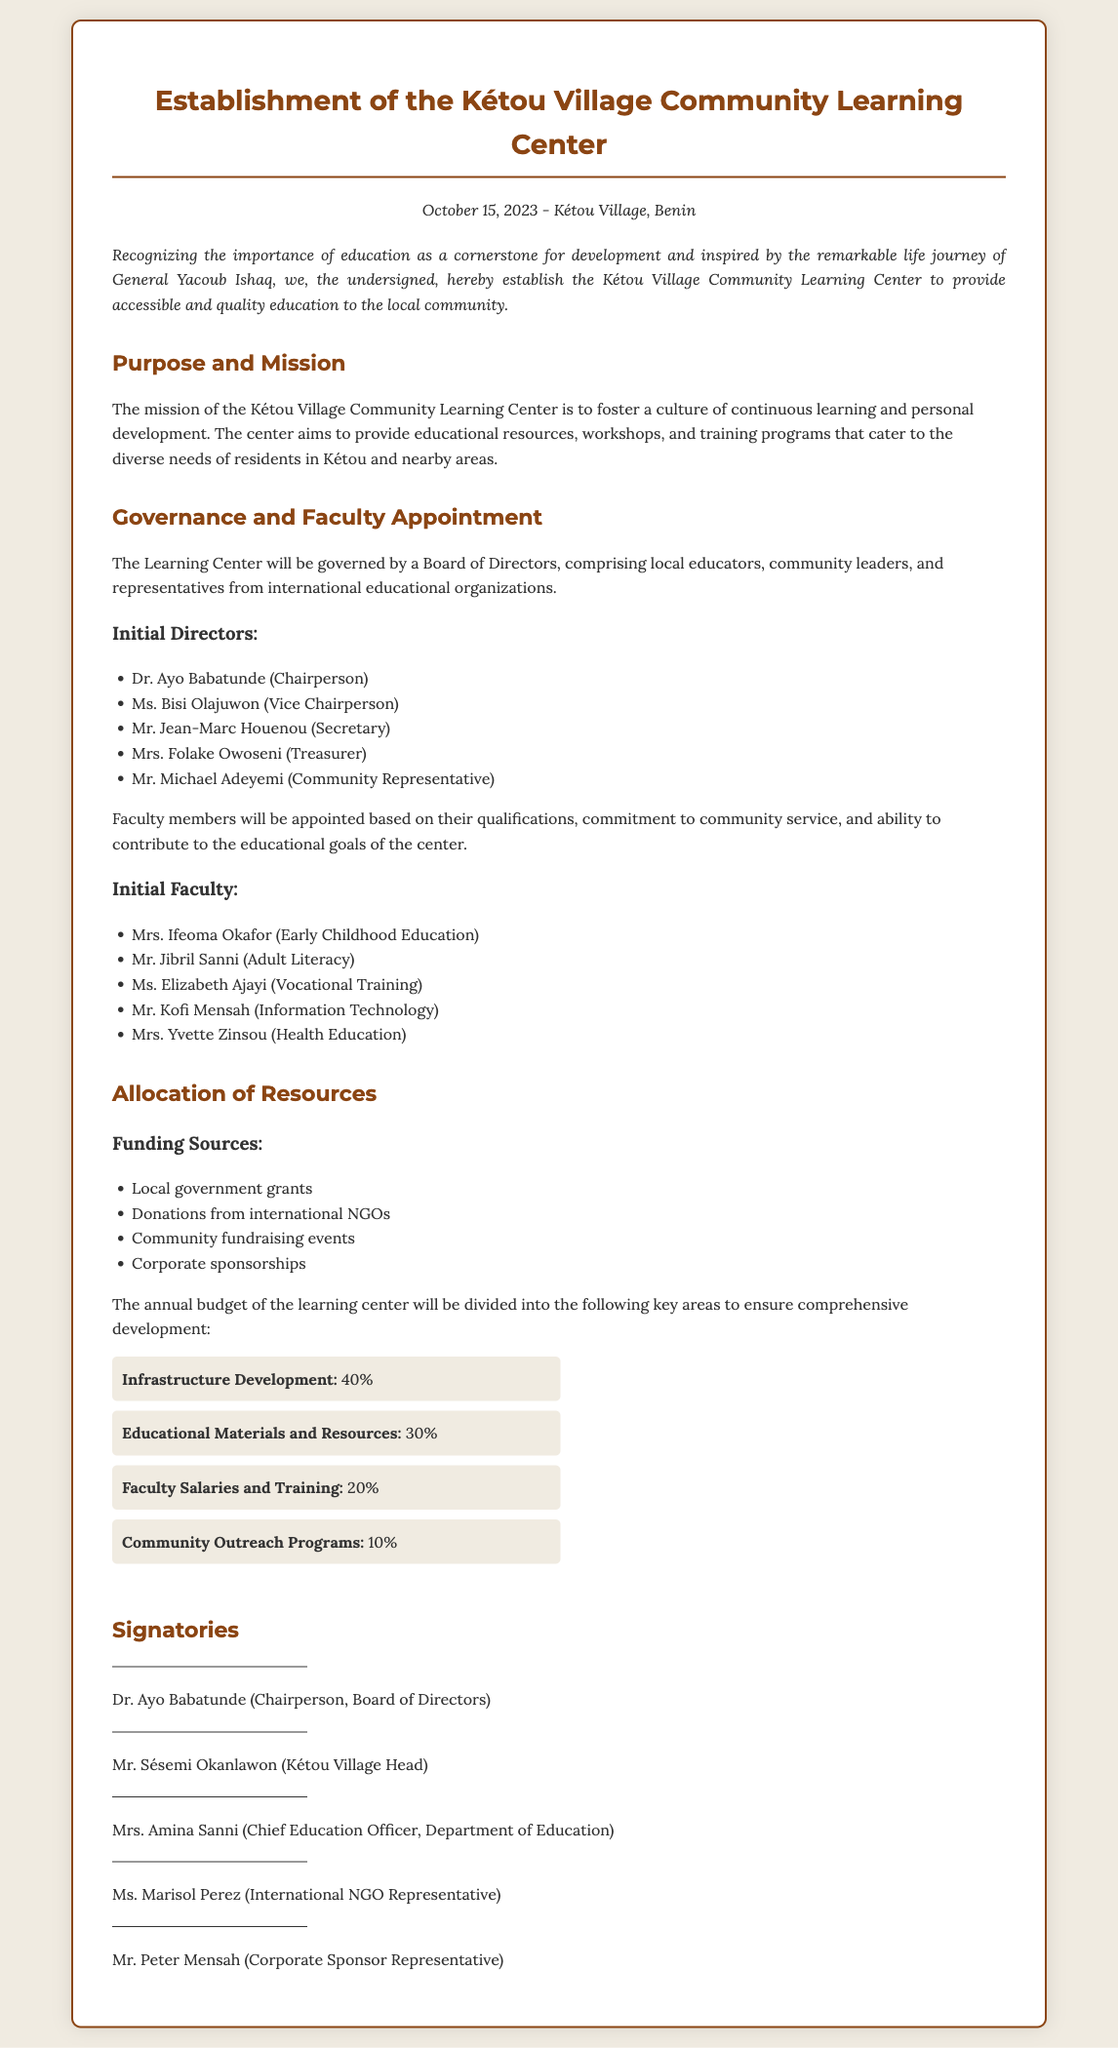What is the date of the establishment? The date mentioned in the document is October 15, 2023.
Answer: October 15, 2023 Who is the Chairperson of the Board of Directors? The document lists Dr. Ayo Babatunde as the Chairperson.
Answer: Dr. Ayo Babatunde What percentage of the budget is allocated to Infrastructure Development? The budget allocation details the percentage for Infrastructure Development as 40%.
Answer: 40% How many faculty members are initially appointed? The document lists five faculty members who are appointed initially.
Answer: Five What is the primary mission of the Kétou Village Community Learning Center? The mission described is to foster a culture of continuous learning and personal development.
Answer: To foster a culture of continuous learning and personal development Which position is held by Ms. Bisi Olajuwon? The document specifies that Ms. Bisi Olajuwon is the Vice Chairperson.
Answer: Vice Chairperson What funding source is mentioned for the learning center? The document identifies local government grants as one of the funding sources.
Answer: Local government grants What role does Mrs. Amina Sanni hold? The document states that Mrs. Amina Sanni is the Chief Education Officer.
Answer: Chief Education Officer 